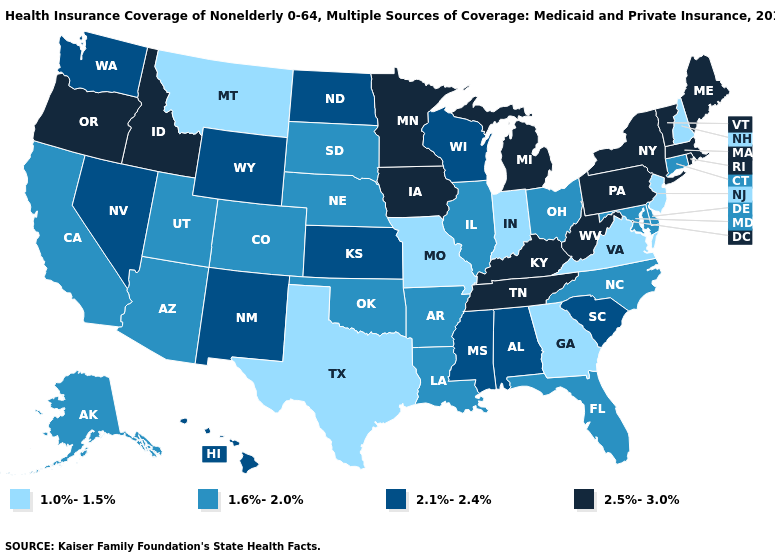What is the lowest value in states that border Texas?
Short answer required. 1.6%-2.0%. Among the states that border Delaware , which have the highest value?
Be succinct. Pennsylvania. What is the value of Michigan?
Be succinct. 2.5%-3.0%. What is the value of Nebraska?
Quick response, please. 1.6%-2.0%. Does the map have missing data?
Concise answer only. No. Which states have the highest value in the USA?
Answer briefly. Idaho, Iowa, Kentucky, Maine, Massachusetts, Michigan, Minnesota, New York, Oregon, Pennsylvania, Rhode Island, Tennessee, Vermont, West Virginia. What is the value of Oregon?
Quick response, please. 2.5%-3.0%. Name the states that have a value in the range 2.1%-2.4%?
Keep it brief. Alabama, Hawaii, Kansas, Mississippi, Nevada, New Mexico, North Dakota, South Carolina, Washington, Wisconsin, Wyoming. Does Iowa have the highest value in the USA?
Quick response, please. Yes. Which states have the highest value in the USA?
Give a very brief answer. Idaho, Iowa, Kentucky, Maine, Massachusetts, Michigan, Minnesota, New York, Oregon, Pennsylvania, Rhode Island, Tennessee, Vermont, West Virginia. How many symbols are there in the legend?
Keep it brief. 4. What is the value of New Jersey?
Keep it brief. 1.0%-1.5%. Among the states that border Alabama , which have the highest value?
Quick response, please. Tennessee. Name the states that have a value in the range 2.1%-2.4%?
Keep it brief. Alabama, Hawaii, Kansas, Mississippi, Nevada, New Mexico, North Dakota, South Carolina, Washington, Wisconsin, Wyoming. 